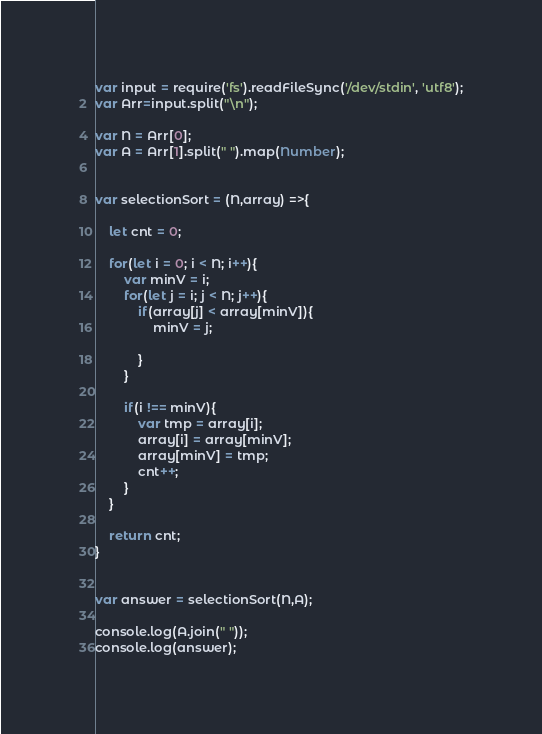Convert code to text. <code><loc_0><loc_0><loc_500><loc_500><_JavaScript_>var input = require('fs').readFileSync('/dev/stdin', 'utf8');
var Arr=input.split("\n");

var N = Arr[0];
var A = Arr[1].split(" ").map(Number);


var selectionSort = (N,array) =>{
    
    let cnt = 0;
    
    for(let i = 0; i < N; i++){
        var minV = i;
        for(let j = i; j < N; j++){
            if(array[j] < array[minV]){
                minV = j;
                
            }
        }
        
      	if(i !== minV){
        	var tmp = array[i];
        	array[i] = array[minV];
        	array[minV] = tmp;
      	    cnt++;
        }
    }

    return cnt;
}


var answer = selectionSort(N,A);

console.log(A.join(" "));
console.log(answer);


</code> 